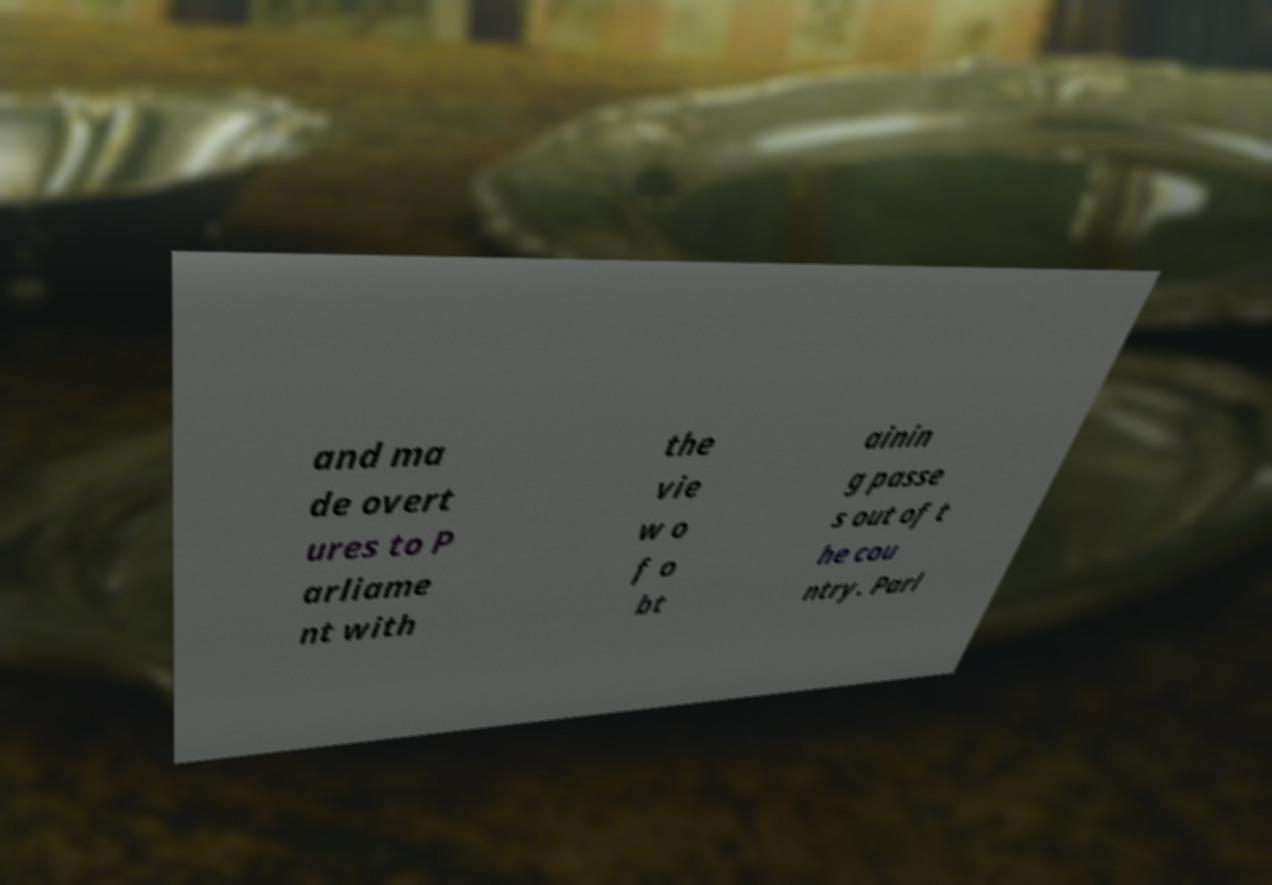I need the written content from this picture converted into text. Can you do that? and ma de overt ures to P arliame nt with the vie w o f o bt ainin g passe s out of t he cou ntry. Parl 